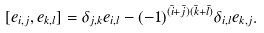<formula> <loc_0><loc_0><loc_500><loc_500>[ e _ { i , j } , e _ { k , l } ] = \delta _ { j , k } e _ { i , l } - ( - 1 ) ^ { ( \bar { i } + \bar { j } ) ( \bar { k } + \bar { l } ) } \delta _ { i , l } e _ { k , j } .</formula> 